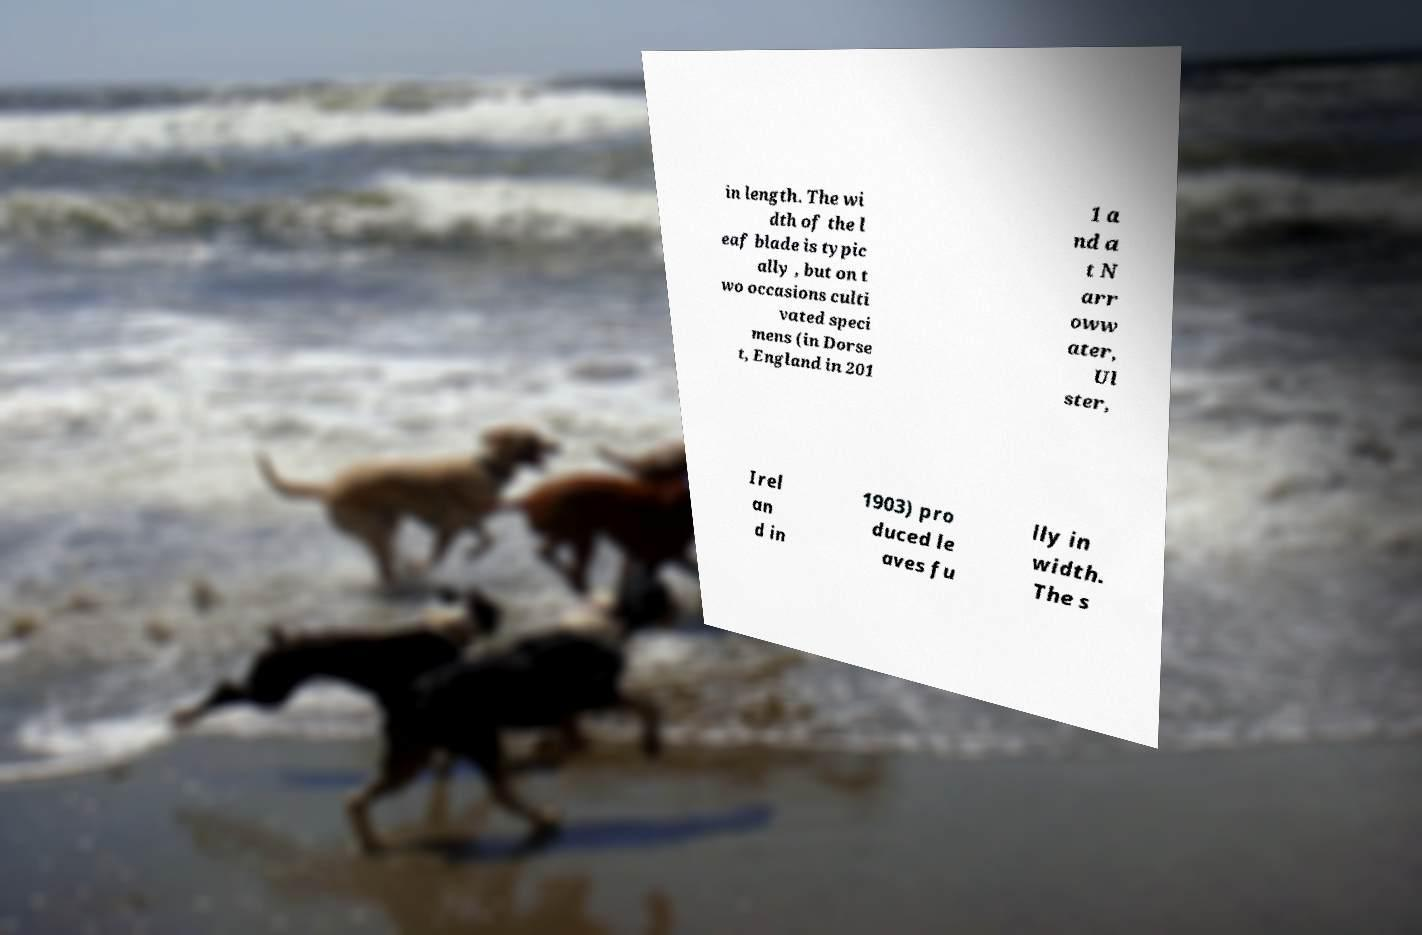For documentation purposes, I need the text within this image transcribed. Could you provide that? in length. The wi dth of the l eaf blade is typic ally , but on t wo occasions culti vated speci mens (in Dorse t, England in 201 1 a nd a t N arr oww ater, Ul ster, Irel an d in 1903) pro duced le aves fu lly in width. The s 